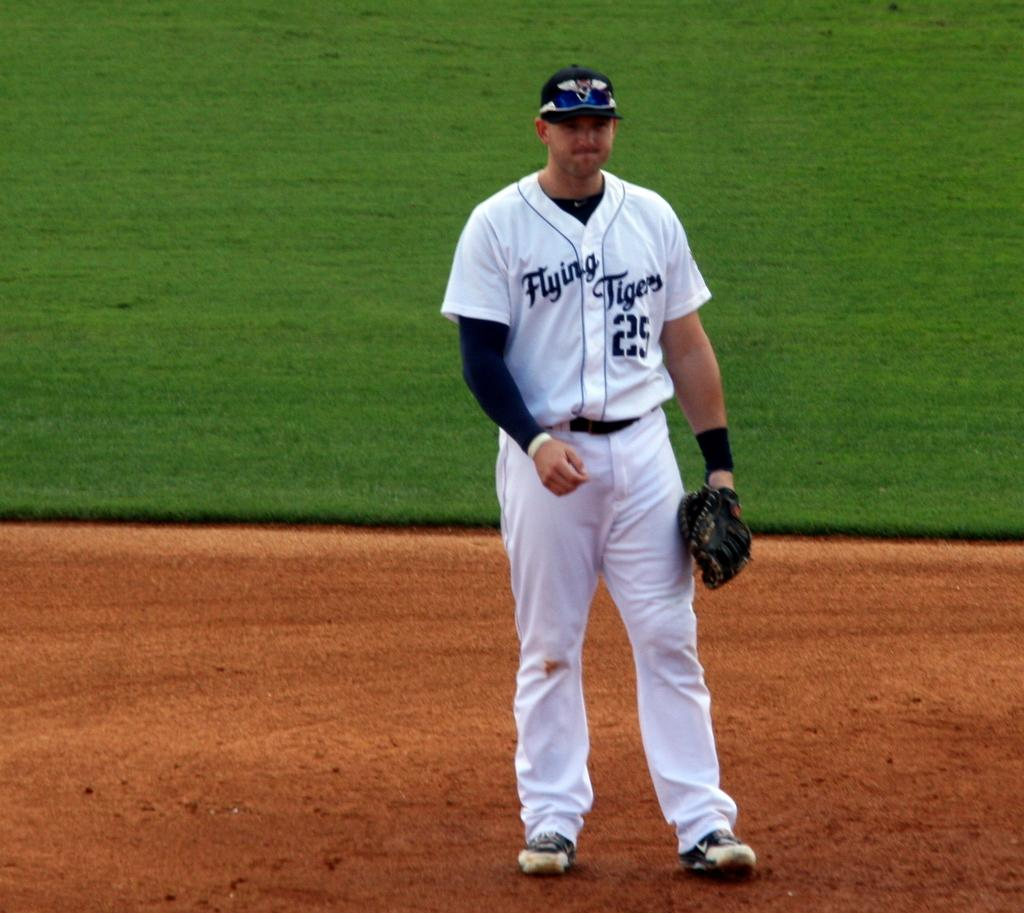Provide a one-sentence caption for the provided image. Flying Tigers baseball player #25 stands in the infield with his mitt. 